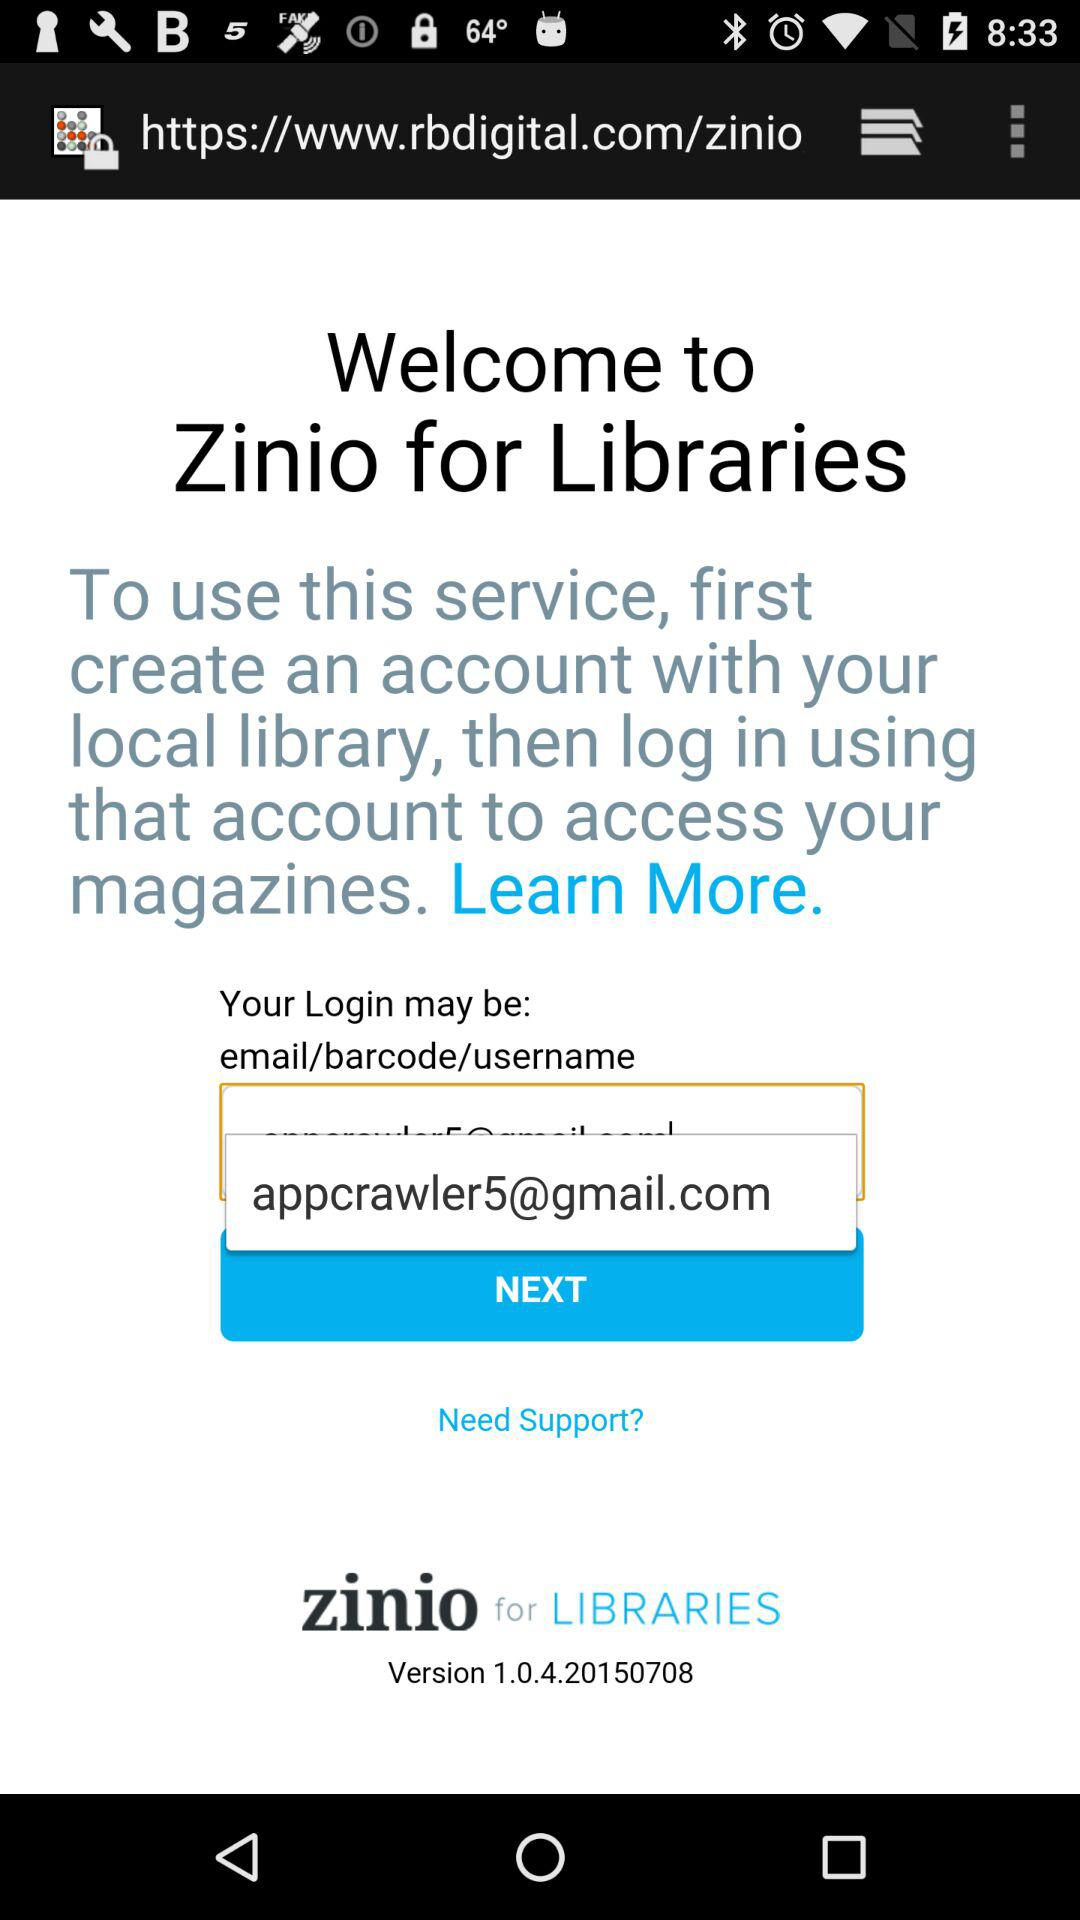What do we do to use the service? To use the service, you need to create an account with your local library, then log in using that account to access your magazines. 